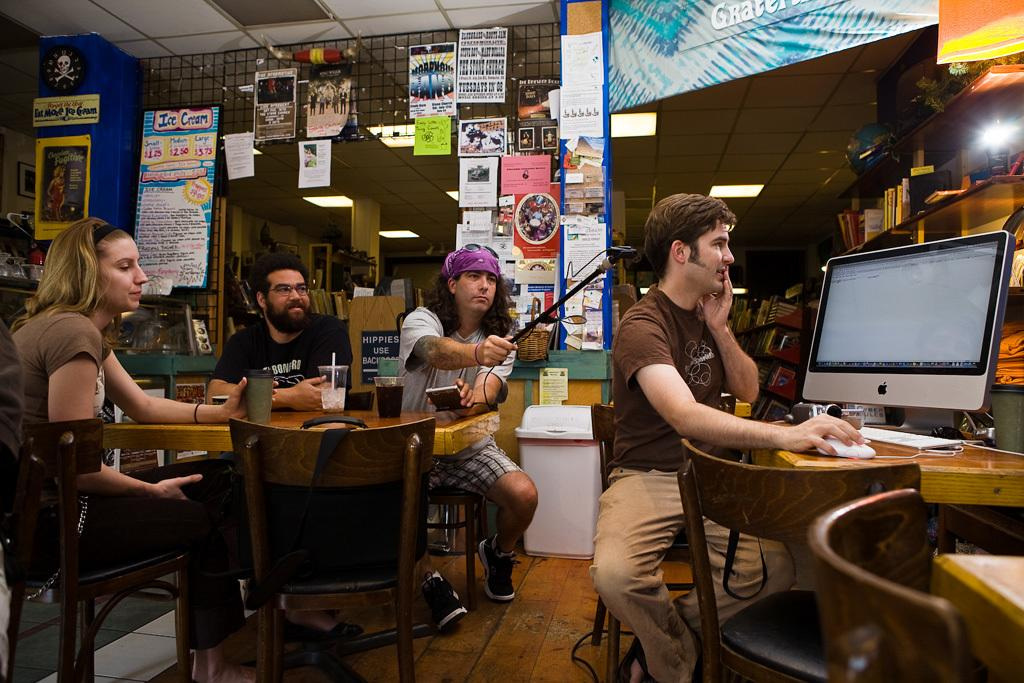What is the person in the image wearing? The person is wearing a brown shirt in the image. What is the person doing in the image? The person is sitting in front of a Mac desktop. How many people are sitting behind the person in the brown shirt? There are three people sitting behind the person in the brown shirt. What type of dolls are sitting on the side of the person in the brown shirt? There are no dolls present in the image; it features a person sitting in front of a Mac desktop with three people sitting behind them. 